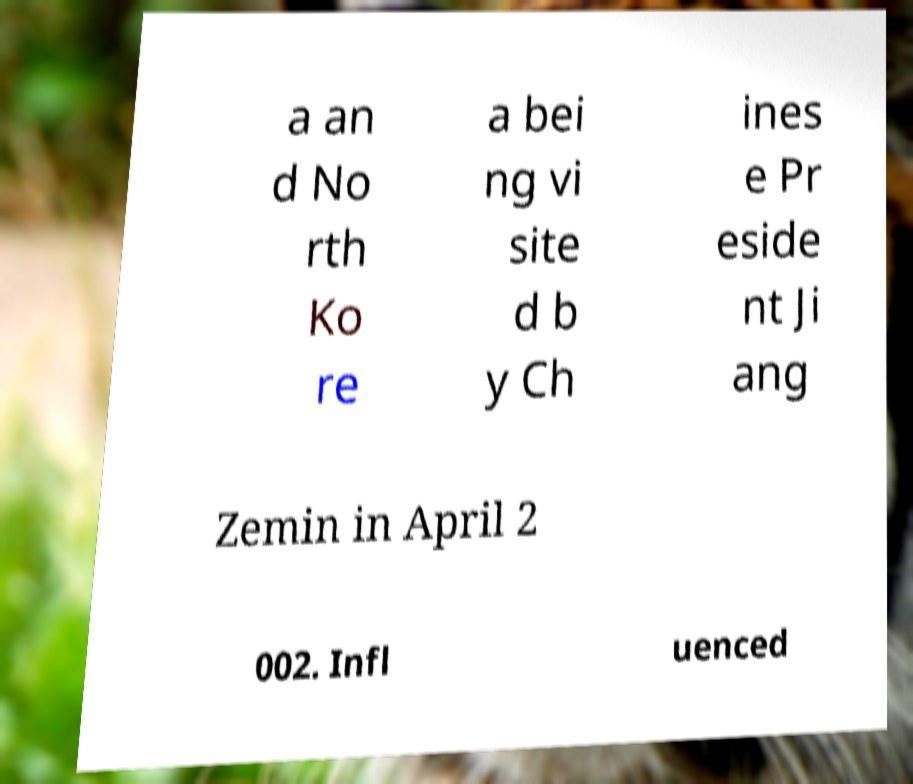Can you read and provide the text displayed in the image?This photo seems to have some interesting text. Can you extract and type it out for me? a an d No rth Ko re a bei ng vi site d b y Ch ines e Pr eside nt Ji ang Zemin in April 2 002. Infl uenced 